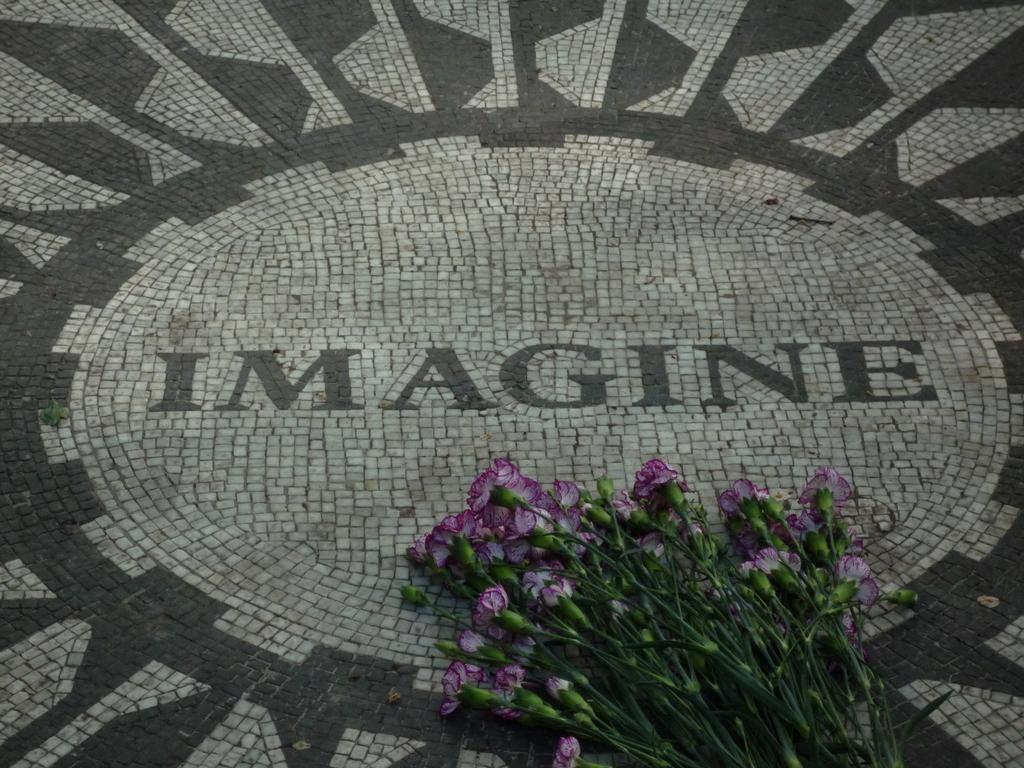What type of plant life is present in the image? There are stems with flowers and buds in the image. How are the stems, flowers, and buds arranged in the image? The stems, flowers, and buds are placed on the floor. Is there any text visible in the image? Yes, there is text visible on the floor in the image. What type of baseball equipment can be seen in the image? There is no baseball equipment present in the image; it features stems with flowers and buds, as well as text on the floor. What type of crime is being committed in the image? There is no crime being committed in the image; it is a still image of stems with flowers and buds, and text on the floor. 